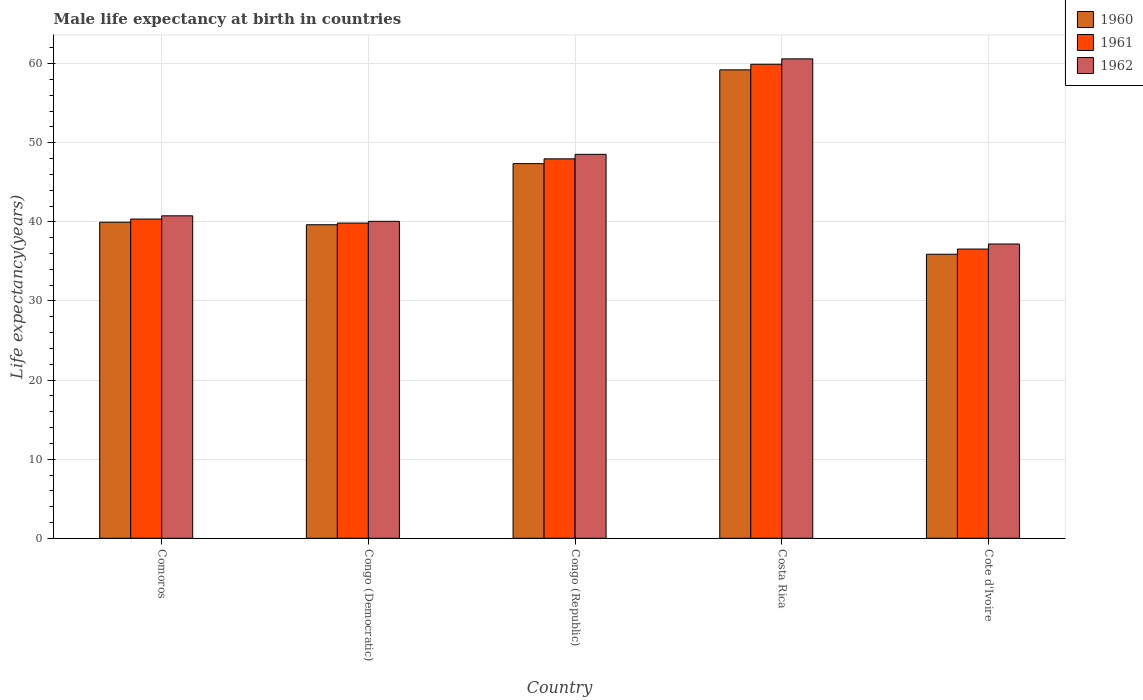How many different coloured bars are there?
Provide a short and direct response. 3. How many groups of bars are there?
Give a very brief answer. 5. Are the number of bars on each tick of the X-axis equal?
Keep it short and to the point. Yes. How many bars are there on the 5th tick from the left?
Your answer should be very brief. 3. How many bars are there on the 3rd tick from the right?
Provide a short and direct response. 3. What is the label of the 1st group of bars from the left?
Ensure brevity in your answer.  Comoros. In how many cases, is the number of bars for a given country not equal to the number of legend labels?
Offer a very short reply. 0. What is the male life expectancy at birth in 1962 in Cote d'Ivoire?
Ensure brevity in your answer.  37.21. Across all countries, what is the maximum male life expectancy at birth in 1960?
Your answer should be compact. 59.22. Across all countries, what is the minimum male life expectancy at birth in 1960?
Make the answer very short. 35.91. In which country was the male life expectancy at birth in 1962 maximum?
Your answer should be very brief. Costa Rica. In which country was the male life expectancy at birth in 1962 minimum?
Offer a very short reply. Cote d'Ivoire. What is the total male life expectancy at birth in 1962 in the graph?
Your answer should be compact. 227.2. What is the difference between the male life expectancy at birth in 1960 in Congo (Democratic) and that in Congo (Republic)?
Your answer should be compact. -7.73. What is the difference between the male life expectancy at birth in 1961 in Costa Rica and the male life expectancy at birth in 1962 in Congo (Democratic)?
Provide a succinct answer. 19.86. What is the average male life expectancy at birth in 1962 per country?
Keep it short and to the point. 45.44. What is the difference between the male life expectancy at birth of/in 1961 and male life expectancy at birth of/in 1960 in Costa Rica?
Keep it short and to the point. 0.71. What is the ratio of the male life expectancy at birth in 1962 in Comoros to that in Costa Rica?
Offer a terse response. 0.67. What is the difference between the highest and the second highest male life expectancy at birth in 1962?
Offer a very short reply. 7.77. What is the difference between the highest and the lowest male life expectancy at birth in 1960?
Offer a terse response. 23.31. Is the sum of the male life expectancy at birth in 1961 in Congo (Democratic) and Cote d'Ivoire greater than the maximum male life expectancy at birth in 1960 across all countries?
Offer a terse response. Yes. Is it the case that in every country, the sum of the male life expectancy at birth in 1962 and male life expectancy at birth in 1961 is greater than the male life expectancy at birth in 1960?
Your answer should be very brief. Yes. How many bars are there?
Provide a short and direct response. 15. Are all the bars in the graph horizontal?
Provide a short and direct response. No. How many countries are there in the graph?
Give a very brief answer. 5. What is the difference between two consecutive major ticks on the Y-axis?
Provide a succinct answer. 10. Are the values on the major ticks of Y-axis written in scientific E-notation?
Provide a succinct answer. No. Does the graph contain any zero values?
Ensure brevity in your answer.  No. Where does the legend appear in the graph?
Make the answer very short. Top right. How are the legend labels stacked?
Provide a short and direct response. Vertical. What is the title of the graph?
Offer a very short reply. Male life expectancy at birth in countries. What is the label or title of the X-axis?
Offer a terse response. Country. What is the label or title of the Y-axis?
Your answer should be compact. Life expectancy(years). What is the Life expectancy(years) of 1960 in Comoros?
Your response must be concise. 39.96. What is the Life expectancy(years) of 1961 in Comoros?
Your answer should be very brief. 40.36. What is the Life expectancy(years) of 1962 in Comoros?
Your answer should be very brief. 40.77. What is the Life expectancy(years) of 1960 in Congo (Democratic)?
Keep it short and to the point. 39.64. What is the Life expectancy(years) of 1961 in Congo (Democratic)?
Your response must be concise. 39.85. What is the Life expectancy(years) of 1962 in Congo (Democratic)?
Your answer should be compact. 40.07. What is the Life expectancy(years) of 1960 in Congo (Republic)?
Provide a short and direct response. 47.37. What is the Life expectancy(years) of 1961 in Congo (Republic)?
Your answer should be very brief. 47.97. What is the Life expectancy(years) of 1962 in Congo (Republic)?
Keep it short and to the point. 48.54. What is the Life expectancy(years) in 1960 in Costa Rica?
Make the answer very short. 59.22. What is the Life expectancy(years) in 1961 in Costa Rica?
Offer a very short reply. 59.93. What is the Life expectancy(years) of 1962 in Costa Rica?
Ensure brevity in your answer.  60.62. What is the Life expectancy(years) of 1960 in Cote d'Ivoire?
Your answer should be compact. 35.91. What is the Life expectancy(years) of 1961 in Cote d'Ivoire?
Keep it short and to the point. 36.57. What is the Life expectancy(years) in 1962 in Cote d'Ivoire?
Your response must be concise. 37.21. Across all countries, what is the maximum Life expectancy(years) of 1960?
Provide a succinct answer. 59.22. Across all countries, what is the maximum Life expectancy(years) of 1961?
Offer a terse response. 59.93. Across all countries, what is the maximum Life expectancy(years) in 1962?
Your response must be concise. 60.62. Across all countries, what is the minimum Life expectancy(years) of 1960?
Provide a short and direct response. 35.91. Across all countries, what is the minimum Life expectancy(years) of 1961?
Keep it short and to the point. 36.57. Across all countries, what is the minimum Life expectancy(years) of 1962?
Provide a succinct answer. 37.21. What is the total Life expectancy(years) in 1960 in the graph?
Your response must be concise. 222.1. What is the total Life expectancy(years) in 1961 in the graph?
Your answer should be very brief. 224.69. What is the total Life expectancy(years) of 1962 in the graph?
Provide a succinct answer. 227.2. What is the difference between the Life expectancy(years) of 1960 in Comoros and that in Congo (Democratic)?
Offer a very short reply. 0.32. What is the difference between the Life expectancy(years) in 1961 in Comoros and that in Congo (Democratic)?
Your answer should be very brief. 0.51. What is the difference between the Life expectancy(years) of 1962 in Comoros and that in Congo (Democratic)?
Your answer should be compact. 0.7. What is the difference between the Life expectancy(years) in 1960 in Comoros and that in Congo (Republic)?
Make the answer very short. -7.41. What is the difference between the Life expectancy(years) of 1961 in Comoros and that in Congo (Republic)?
Keep it short and to the point. -7.61. What is the difference between the Life expectancy(years) of 1962 in Comoros and that in Congo (Republic)?
Provide a succinct answer. -7.77. What is the difference between the Life expectancy(years) of 1960 in Comoros and that in Costa Rica?
Your answer should be very brief. -19.26. What is the difference between the Life expectancy(years) in 1961 in Comoros and that in Costa Rica?
Provide a short and direct response. -19.57. What is the difference between the Life expectancy(years) of 1962 in Comoros and that in Costa Rica?
Provide a succinct answer. -19.85. What is the difference between the Life expectancy(years) of 1960 in Comoros and that in Cote d'Ivoire?
Your response must be concise. 4.05. What is the difference between the Life expectancy(years) in 1961 in Comoros and that in Cote d'Ivoire?
Your answer should be compact. 3.79. What is the difference between the Life expectancy(years) of 1962 in Comoros and that in Cote d'Ivoire?
Your answer should be compact. 3.56. What is the difference between the Life expectancy(years) of 1960 in Congo (Democratic) and that in Congo (Republic)?
Keep it short and to the point. -7.73. What is the difference between the Life expectancy(years) of 1961 in Congo (Democratic) and that in Congo (Republic)?
Offer a terse response. -8.12. What is the difference between the Life expectancy(years) of 1962 in Congo (Democratic) and that in Congo (Republic)?
Provide a short and direct response. -8.47. What is the difference between the Life expectancy(years) in 1960 in Congo (Democratic) and that in Costa Rica?
Your answer should be compact. -19.58. What is the difference between the Life expectancy(years) in 1961 in Congo (Democratic) and that in Costa Rica?
Your answer should be very brief. -20.08. What is the difference between the Life expectancy(years) in 1962 in Congo (Democratic) and that in Costa Rica?
Give a very brief answer. -20.54. What is the difference between the Life expectancy(years) in 1960 in Congo (Democratic) and that in Cote d'Ivoire?
Keep it short and to the point. 3.73. What is the difference between the Life expectancy(years) in 1961 in Congo (Democratic) and that in Cote d'Ivoire?
Your answer should be very brief. 3.29. What is the difference between the Life expectancy(years) in 1962 in Congo (Democratic) and that in Cote d'Ivoire?
Ensure brevity in your answer.  2.87. What is the difference between the Life expectancy(years) in 1960 in Congo (Republic) and that in Costa Rica?
Give a very brief answer. -11.86. What is the difference between the Life expectancy(years) in 1961 in Congo (Republic) and that in Costa Rica?
Your response must be concise. -11.96. What is the difference between the Life expectancy(years) in 1962 in Congo (Republic) and that in Costa Rica?
Your response must be concise. -12.07. What is the difference between the Life expectancy(years) in 1960 in Congo (Republic) and that in Cote d'Ivoire?
Ensure brevity in your answer.  11.46. What is the difference between the Life expectancy(years) in 1961 in Congo (Republic) and that in Cote d'Ivoire?
Ensure brevity in your answer.  11.41. What is the difference between the Life expectancy(years) of 1962 in Congo (Republic) and that in Cote d'Ivoire?
Give a very brief answer. 11.34. What is the difference between the Life expectancy(years) in 1960 in Costa Rica and that in Cote d'Ivoire?
Keep it short and to the point. 23.32. What is the difference between the Life expectancy(years) of 1961 in Costa Rica and that in Cote d'Ivoire?
Keep it short and to the point. 23.36. What is the difference between the Life expectancy(years) of 1962 in Costa Rica and that in Cote d'Ivoire?
Keep it short and to the point. 23.41. What is the difference between the Life expectancy(years) of 1960 in Comoros and the Life expectancy(years) of 1961 in Congo (Democratic)?
Ensure brevity in your answer.  0.1. What is the difference between the Life expectancy(years) of 1960 in Comoros and the Life expectancy(years) of 1962 in Congo (Democratic)?
Make the answer very short. -0.11. What is the difference between the Life expectancy(years) in 1961 in Comoros and the Life expectancy(years) in 1962 in Congo (Democratic)?
Keep it short and to the point. 0.29. What is the difference between the Life expectancy(years) of 1960 in Comoros and the Life expectancy(years) of 1961 in Congo (Republic)?
Give a very brief answer. -8.01. What is the difference between the Life expectancy(years) of 1960 in Comoros and the Life expectancy(years) of 1962 in Congo (Republic)?
Your answer should be very brief. -8.58. What is the difference between the Life expectancy(years) in 1961 in Comoros and the Life expectancy(years) in 1962 in Congo (Republic)?
Ensure brevity in your answer.  -8.18. What is the difference between the Life expectancy(years) in 1960 in Comoros and the Life expectancy(years) in 1961 in Costa Rica?
Give a very brief answer. -19.97. What is the difference between the Life expectancy(years) of 1960 in Comoros and the Life expectancy(years) of 1962 in Costa Rica?
Ensure brevity in your answer.  -20.66. What is the difference between the Life expectancy(years) in 1961 in Comoros and the Life expectancy(years) in 1962 in Costa Rica?
Give a very brief answer. -20.25. What is the difference between the Life expectancy(years) in 1960 in Comoros and the Life expectancy(years) in 1961 in Cote d'Ivoire?
Give a very brief answer. 3.39. What is the difference between the Life expectancy(years) of 1960 in Comoros and the Life expectancy(years) of 1962 in Cote d'Ivoire?
Keep it short and to the point. 2.75. What is the difference between the Life expectancy(years) in 1961 in Comoros and the Life expectancy(years) in 1962 in Cote d'Ivoire?
Ensure brevity in your answer.  3.15. What is the difference between the Life expectancy(years) in 1960 in Congo (Democratic) and the Life expectancy(years) in 1961 in Congo (Republic)?
Make the answer very short. -8.33. What is the difference between the Life expectancy(years) of 1960 in Congo (Democratic) and the Life expectancy(years) of 1962 in Congo (Republic)?
Your answer should be very brief. -8.9. What is the difference between the Life expectancy(years) in 1961 in Congo (Democratic) and the Life expectancy(years) in 1962 in Congo (Republic)?
Your response must be concise. -8.69. What is the difference between the Life expectancy(years) in 1960 in Congo (Democratic) and the Life expectancy(years) in 1961 in Costa Rica?
Provide a succinct answer. -20.29. What is the difference between the Life expectancy(years) of 1960 in Congo (Democratic) and the Life expectancy(years) of 1962 in Costa Rica?
Make the answer very short. -20.98. What is the difference between the Life expectancy(years) in 1961 in Congo (Democratic) and the Life expectancy(years) in 1962 in Costa Rica?
Your answer should be compact. -20.76. What is the difference between the Life expectancy(years) of 1960 in Congo (Democratic) and the Life expectancy(years) of 1961 in Cote d'Ivoire?
Provide a short and direct response. 3.07. What is the difference between the Life expectancy(years) of 1960 in Congo (Democratic) and the Life expectancy(years) of 1962 in Cote d'Ivoire?
Provide a short and direct response. 2.43. What is the difference between the Life expectancy(years) in 1961 in Congo (Democratic) and the Life expectancy(years) in 1962 in Cote d'Ivoire?
Offer a very short reply. 2.65. What is the difference between the Life expectancy(years) in 1960 in Congo (Republic) and the Life expectancy(years) in 1961 in Costa Rica?
Offer a very short reply. -12.56. What is the difference between the Life expectancy(years) of 1960 in Congo (Republic) and the Life expectancy(years) of 1962 in Costa Rica?
Keep it short and to the point. -13.25. What is the difference between the Life expectancy(years) of 1961 in Congo (Republic) and the Life expectancy(years) of 1962 in Costa Rica?
Make the answer very short. -12.64. What is the difference between the Life expectancy(years) in 1960 in Congo (Republic) and the Life expectancy(years) in 1961 in Cote d'Ivoire?
Offer a terse response. 10.8. What is the difference between the Life expectancy(years) in 1960 in Congo (Republic) and the Life expectancy(years) in 1962 in Cote d'Ivoire?
Your response must be concise. 10.16. What is the difference between the Life expectancy(years) in 1961 in Congo (Republic) and the Life expectancy(years) in 1962 in Cote d'Ivoire?
Your answer should be compact. 10.77. What is the difference between the Life expectancy(years) in 1960 in Costa Rica and the Life expectancy(years) in 1961 in Cote d'Ivoire?
Ensure brevity in your answer.  22.66. What is the difference between the Life expectancy(years) in 1960 in Costa Rica and the Life expectancy(years) in 1962 in Cote d'Ivoire?
Offer a terse response. 22.02. What is the difference between the Life expectancy(years) of 1961 in Costa Rica and the Life expectancy(years) of 1962 in Cote d'Ivoire?
Provide a short and direct response. 22.72. What is the average Life expectancy(years) in 1960 per country?
Make the answer very short. 44.42. What is the average Life expectancy(years) in 1961 per country?
Provide a short and direct response. 44.94. What is the average Life expectancy(years) of 1962 per country?
Offer a terse response. 45.44. What is the difference between the Life expectancy(years) of 1960 and Life expectancy(years) of 1961 in Comoros?
Provide a short and direct response. -0.4. What is the difference between the Life expectancy(years) in 1960 and Life expectancy(years) in 1962 in Comoros?
Give a very brief answer. -0.81. What is the difference between the Life expectancy(years) in 1961 and Life expectancy(years) in 1962 in Comoros?
Offer a very short reply. -0.41. What is the difference between the Life expectancy(years) in 1960 and Life expectancy(years) in 1961 in Congo (Democratic)?
Offer a very short reply. -0.21. What is the difference between the Life expectancy(years) in 1960 and Life expectancy(years) in 1962 in Congo (Democratic)?
Keep it short and to the point. -0.43. What is the difference between the Life expectancy(years) in 1961 and Life expectancy(years) in 1962 in Congo (Democratic)?
Your answer should be very brief. -0.22. What is the difference between the Life expectancy(years) in 1960 and Life expectancy(years) in 1961 in Congo (Republic)?
Your response must be concise. -0.6. What is the difference between the Life expectancy(years) of 1960 and Life expectancy(years) of 1962 in Congo (Republic)?
Offer a very short reply. -1.18. What is the difference between the Life expectancy(years) of 1961 and Life expectancy(years) of 1962 in Congo (Republic)?
Offer a terse response. -0.57. What is the difference between the Life expectancy(years) in 1960 and Life expectancy(years) in 1961 in Costa Rica?
Give a very brief answer. -0.71. What is the difference between the Life expectancy(years) in 1960 and Life expectancy(years) in 1962 in Costa Rica?
Ensure brevity in your answer.  -1.39. What is the difference between the Life expectancy(years) in 1961 and Life expectancy(years) in 1962 in Costa Rica?
Your answer should be very brief. -0.68. What is the difference between the Life expectancy(years) in 1960 and Life expectancy(years) in 1961 in Cote d'Ivoire?
Your answer should be very brief. -0.66. What is the difference between the Life expectancy(years) in 1960 and Life expectancy(years) in 1962 in Cote d'Ivoire?
Make the answer very short. -1.3. What is the difference between the Life expectancy(years) in 1961 and Life expectancy(years) in 1962 in Cote d'Ivoire?
Provide a short and direct response. -0.64. What is the ratio of the Life expectancy(years) in 1961 in Comoros to that in Congo (Democratic)?
Ensure brevity in your answer.  1.01. What is the ratio of the Life expectancy(years) in 1962 in Comoros to that in Congo (Democratic)?
Your answer should be very brief. 1.02. What is the ratio of the Life expectancy(years) in 1960 in Comoros to that in Congo (Republic)?
Your response must be concise. 0.84. What is the ratio of the Life expectancy(years) of 1961 in Comoros to that in Congo (Republic)?
Make the answer very short. 0.84. What is the ratio of the Life expectancy(years) in 1962 in Comoros to that in Congo (Republic)?
Your answer should be very brief. 0.84. What is the ratio of the Life expectancy(years) of 1960 in Comoros to that in Costa Rica?
Give a very brief answer. 0.67. What is the ratio of the Life expectancy(years) of 1961 in Comoros to that in Costa Rica?
Give a very brief answer. 0.67. What is the ratio of the Life expectancy(years) in 1962 in Comoros to that in Costa Rica?
Provide a short and direct response. 0.67. What is the ratio of the Life expectancy(years) of 1960 in Comoros to that in Cote d'Ivoire?
Offer a very short reply. 1.11. What is the ratio of the Life expectancy(years) in 1961 in Comoros to that in Cote d'Ivoire?
Your answer should be compact. 1.1. What is the ratio of the Life expectancy(years) of 1962 in Comoros to that in Cote d'Ivoire?
Keep it short and to the point. 1.1. What is the ratio of the Life expectancy(years) of 1960 in Congo (Democratic) to that in Congo (Republic)?
Give a very brief answer. 0.84. What is the ratio of the Life expectancy(years) in 1961 in Congo (Democratic) to that in Congo (Republic)?
Provide a succinct answer. 0.83. What is the ratio of the Life expectancy(years) in 1962 in Congo (Democratic) to that in Congo (Republic)?
Give a very brief answer. 0.83. What is the ratio of the Life expectancy(years) of 1960 in Congo (Democratic) to that in Costa Rica?
Give a very brief answer. 0.67. What is the ratio of the Life expectancy(years) of 1961 in Congo (Democratic) to that in Costa Rica?
Offer a very short reply. 0.67. What is the ratio of the Life expectancy(years) in 1962 in Congo (Democratic) to that in Costa Rica?
Your answer should be compact. 0.66. What is the ratio of the Life expectancy(years) in 1960 in Congo (Democratic) to that in Cote d'Ivoire?
Offer a terse response. 1.1. What is the ratio of the Life expectancy(years) of 1961 in Congo (Democratic) to that in Cote d'Ivoire?
Make the answer very short. 1.09. What is the ratio of the Life expectancy(years) of 1962 in Congo (Democratic) to that in Cote d'Ivoire?
Provide a succinct answer. 1.08. What is the ratio of the Life expectancy(years) of 1960 in Congo (Republic) to that in Costa Rica?
Your answer should be compact. 0.8. What is the ratio of the Life expectancy(years) of 1961 in Congo (Republic) to that in Costa Rica?
Your answer should be very brief. 0.8. What is the ratio of the Life expectancy(years) in 1962 in Congo (Republic) to that in Costa Rica?
Ensure brevity in your answer.  0.8. What is the ratio of the Life expectancy(years) of 1960 in Congo (Republic) to that in Cote d'Ivoire?
Provide a succinct answer. 1.32. What is the ratio of the Life expectancy(years) in 1961 in Congo (Republic) to that in Cote d'Ivoire?
Give a very brief answer. 1.31. What is the ratio of the Life expectancy(years) in 1962 in Congo (Republic) to that in Cote d'Ivoire?
Keep it short and to the point. 1.3. What is the ratio of the Life expectancy(years) in 1960 in Costa Rica to that in Cote d'Ivoire?
Offer a terse response. 1.65. What is the ratio of the Life expectancy(years) of 1961 in Costa Rica to that in Cote d'Ivoire?
Provide a short and direct response. 1.64. What is the ratio of the Life expectancy(years) of 1962 in Costa Rica to that in Cote d'Ivoire?
Offer a very short reply. 1.63. What is the difference between the highest and the second highest Life expectancy(years) in 1960?
Your response must be concise. 11.86. What is the difference between the highest and the second highest Life expectancy(years) of 1961?
Give a very brief answer. 11.96. What is the difference between the highest and the second highest Life expectancy(years) in 1962?
Offer a very short reply. 12.07. What is the difference between the highest and the lowest Life expectancy(years) in 1960?
Keep it short and to the point. 23.32. What is the difference between the highest and the lowest Life expectancy(years) in 1961?
Provide a short and direct response. 23.36. What is the difference between the highest and the lowest Life expectancy(years) in 1962?
Offer a terse response. 23.41. 